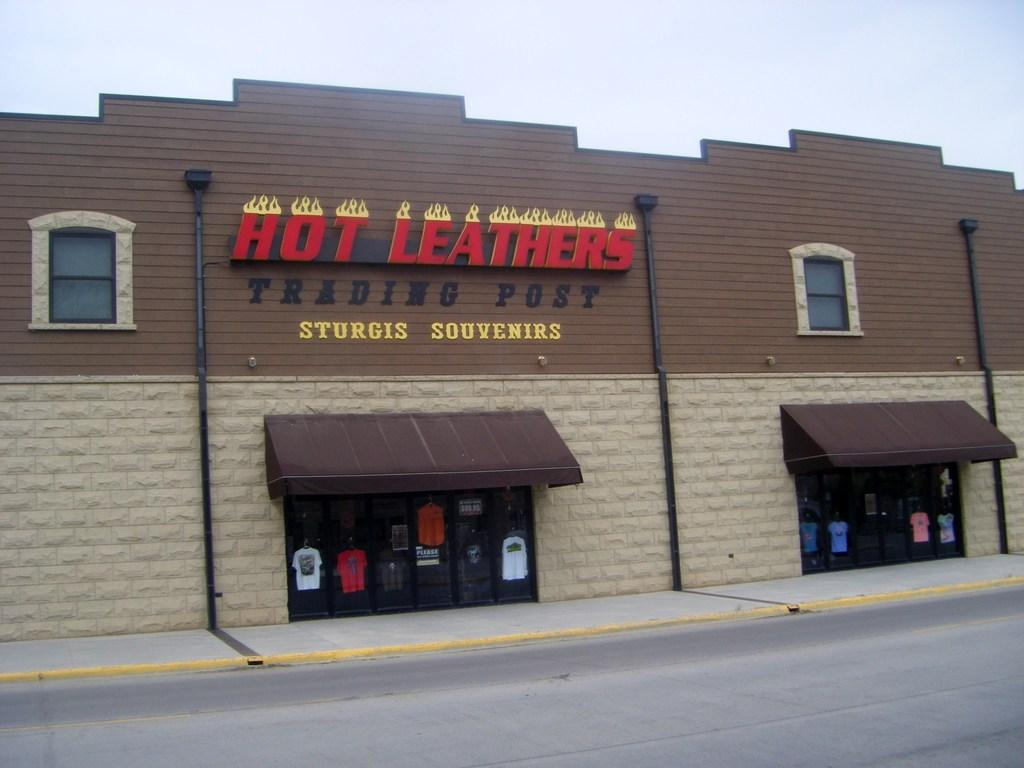What is the main subject in the center of the image? There is a store in the center of the image. What can be seen at the top of the image? The sky is visible at the top of the image. What is located at the bottom of the image? There is a road at the bottom of the image. What type of creature can be seen walking on the floor in the image? There is no creature present in the image, and the floor is not visible. 